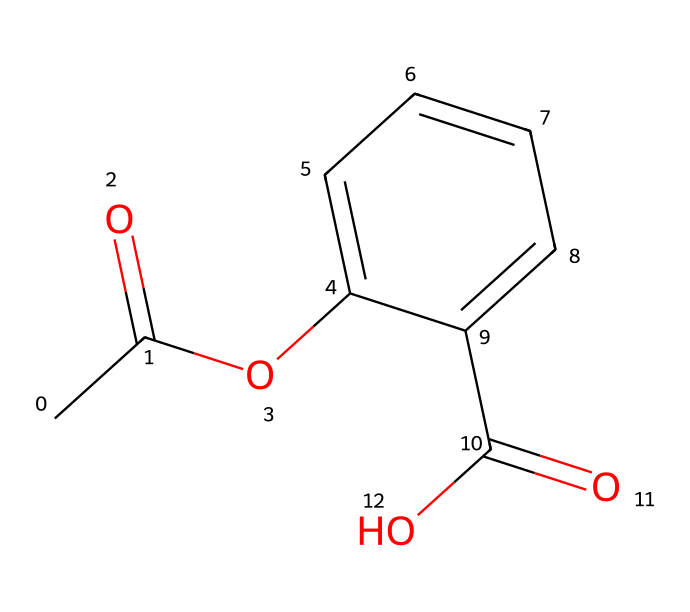What is the functional group present in acetylsalicylic acid? The structure of acetylsalicylic acid includes both an acetic acid (ester) and a carboxylic acid functional group. The presence of the -COOH group indicates that a carboxylic acid functional group is present.
Answer: carboxylic acid How many aromatic rings are in the structure of acetylsalicylic acid? The molecular structure shows that there is one aromatic ring in the compound, specifically the six-membered carbon ring that includes alternating double bonds.
Answer: one What is the total number of carbon atoms in acetylsalicylic acid? Counting the carbon atoms in the structure reveals that there are nine carbon atoms present within the whole molecule, including those in the aromatic ring and in the functional groups.
Answer: nine What type of bonding is primarily seen in acetylsalicylic acid? The chemical structure features single bonds and several double bonds, primarily including carbon-carbon and carbon-oxygen single and double bonds, which are common in organic compounds.
Answer: covalent How many hydroxyl groups are present in acetylsalicylic acid? In examining the structure, we can see that there is one hydroxyl group (-OH) represented in the molecule, specifically attached to the aromatic ring.
Answer: one What is the primary therapeutic use of acetylsalicylic acid? Acetylsalicylic acid, commonly known as aspirin, is primarily used for its anti-inflammatory properties and is often prescribed for pain relief, reducing fever, and in low doses for cardiovascular protection.
Answer: cardiovascular protection Is acetylsalicylic acid classified as a phenol? Yes, acetylsalicylic acid contains a phenolic structure due to the presence of the benzene ring with a hydroxyl group, classifying it under the phenol category.
Answer: yes 